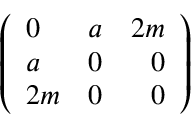<formula> <loc_0><loc_0><loc_500><loc_500>\left ( \begin{array} { l c r } { 0 } & { a } & { 2 m } \\ { a } & { 0 } & { 0 } \\ { 2 m } & { 0 } & { 0 } \end{array} \right )</formula> 